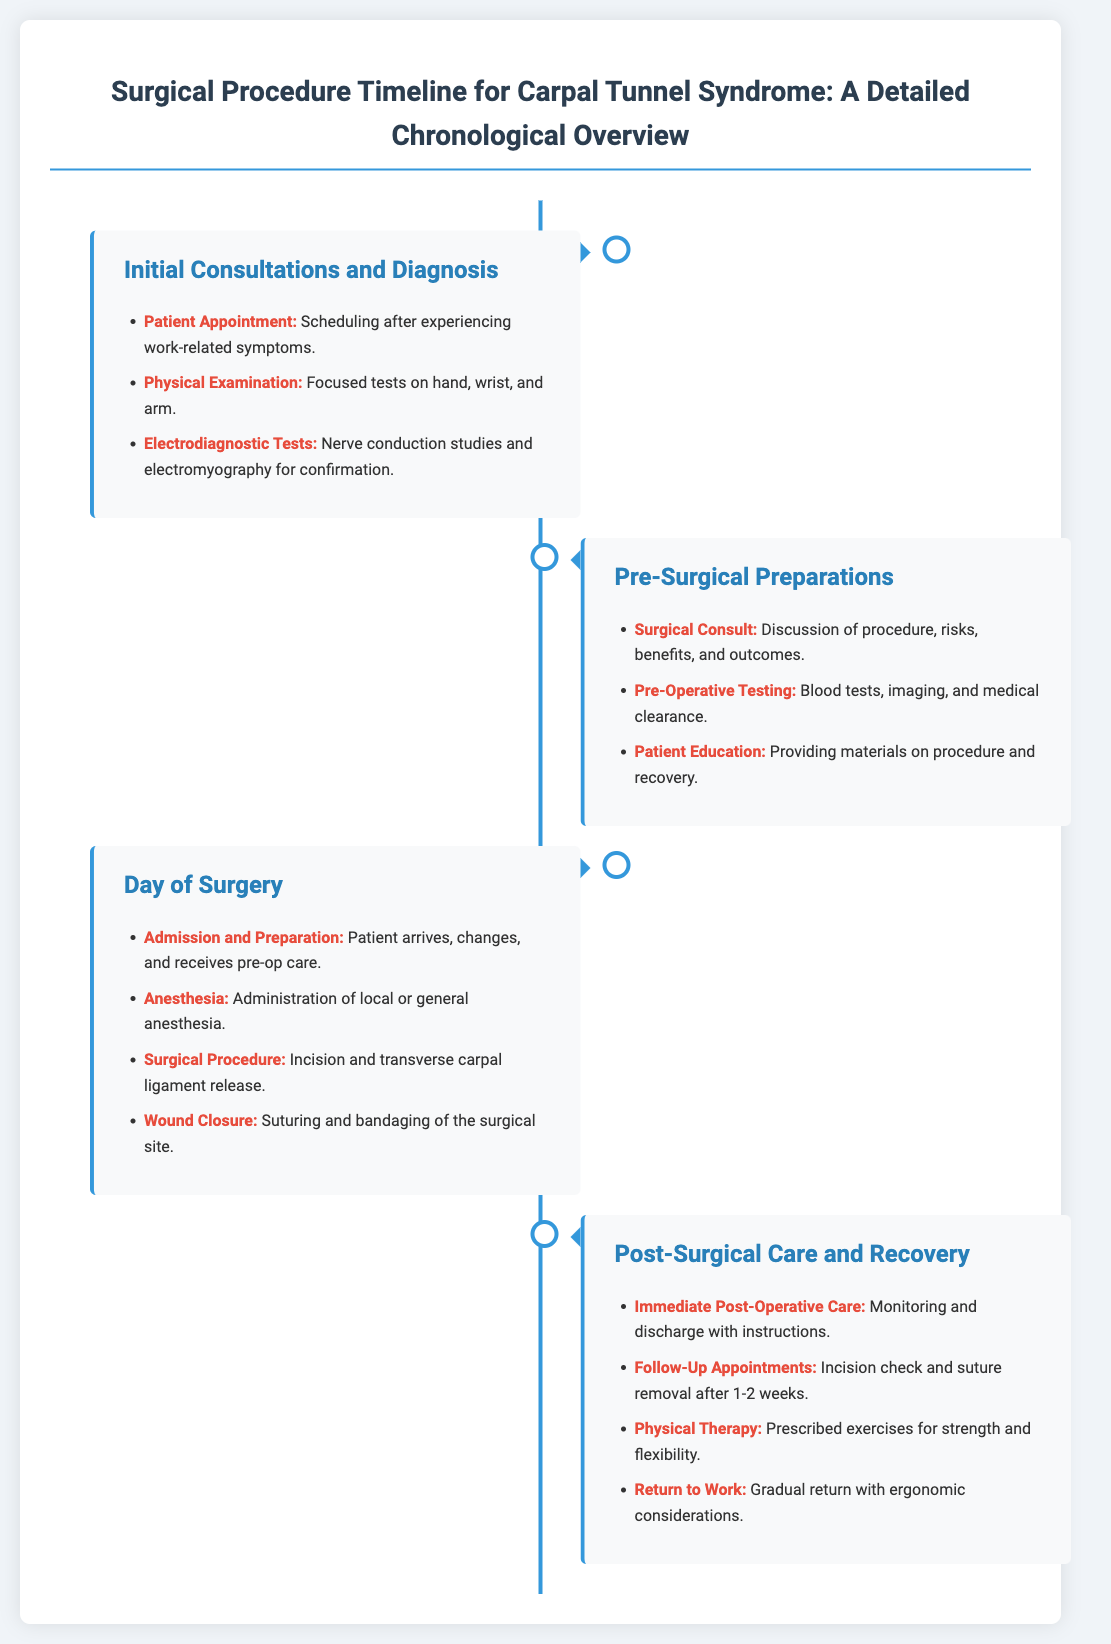What is the first step in the surgical procedure timeline? The first step is identified under "Initial Consultations and Diagnosis," which begins with the patient appointment.
Answer: Patient Appointment What kind of tests are conducted during the initial consultations? The document lists "Electrodiagnostic Tests" which include nerve conduction studies and electromyography.
Answer: Electrodiagnostic Tests How many major sections are in the timeline? The timeline consists of four major sections detailing each stage of the process.
Answer: Four What occurs on the day of surgery related to anesthesia? The document states that "Anesthesia" involves the administration of local or general anesthesia.
Answer: Administration of local or general anesthesia What is included in post-surgical care? The section lists several points, including immediate post-operative care and follow-up appointments.
Answer: Immediate Post-Operative Care How long after surgery are follow-up appointments typically scheduled? The document specifies follow-up appointments take place after 1-2 weeks post-surgery.
Answer: 1-2 weeks What is the purpose of the patient education step? It provides materials on the procedure and recovery to prepare the patient.
Answer: Providing materials on procedure and recovery In which section is the surgical procedure described? The surgical procedure is outlined on the "Day of Surgery" section.
Answer: Day of Surgery What is the main focus of the pre-surgical preparations? The main focus is on discussing the procedure, risks, benefits, and outcomes with the patient.
Answer: Discussion of procedure, risks, benefits, and outcomes 